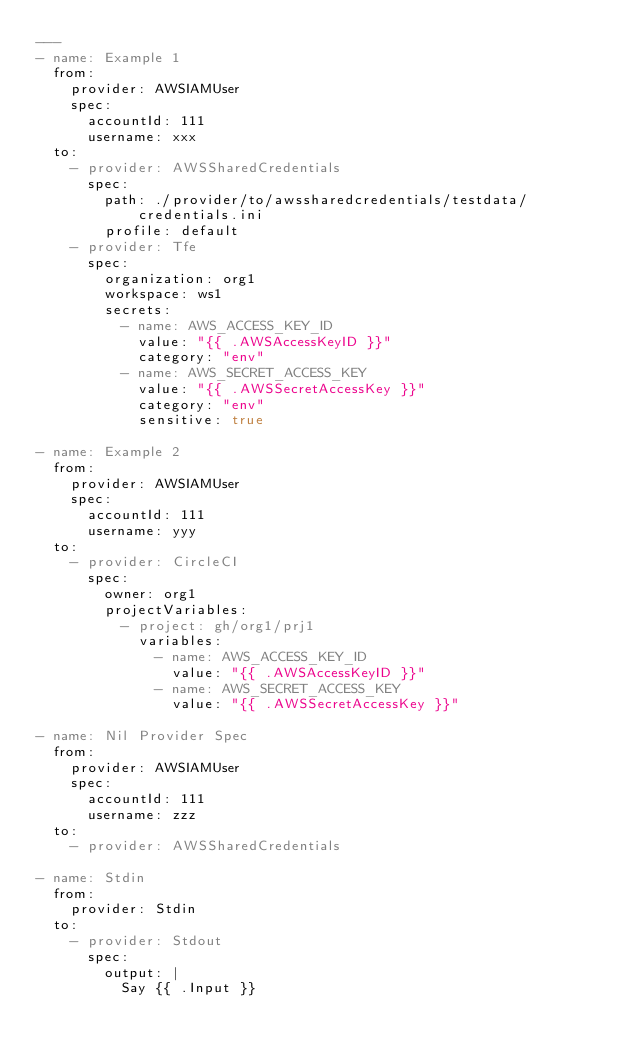<code> <loc_0><loc_0><loc_500><loc_500><_YAML_>---
- name: Example 1
  from:
    provider: AWSIAMUser
    spec:
      accountId: 111
      username: xxx
  to:
    - provider: AWSSharedCredentials
      spec:
        path: ./provider/to/awssharedcredentials/testdata/credentials.ini
        profile: default
    - provider: Tfe
      spec:
        organization: org1
        workspace: ws1
        secrets:
          - name: AWS_ACCESS_KEY_ID
            value: "{{ .AWSAccessKeyID }}"
            category: "env"
          - name: AWS_SECRET_ACCESS_KEY
            value: "{{ .AWSSecretAccessKey }}"
            category: "env"
            sensitive: true

- name: Example 2
  from:
    provider: AWSIAMUser
    spec:
      accountId: 111
      username: yyy
  to:
    - provider: CircleCI
      spec:
        owner: org1
        projectVariables:
          - project: gh/org1/prj1
            variables:
              - name: AWS_ACCESS_KEY_ID
                value: "{{ .AWSAccessKeyID }}"
              - name: AWS_SECRET_ACCESS_KEY
                value: "{{ .AWSSecretAccessKey }}"

- name: Nil Provider Spec
  from:
    provider: AWSIAMUser
    spec:
      accountId: 111
      username: zzz
  to:
    - provider: AWSSharedCredentials

- name: Stdin
  from:
    provider: Stdin
  to:
    - provider: Stdout
      spec:
        output: |
          Say {{ .Input }}
</code> 